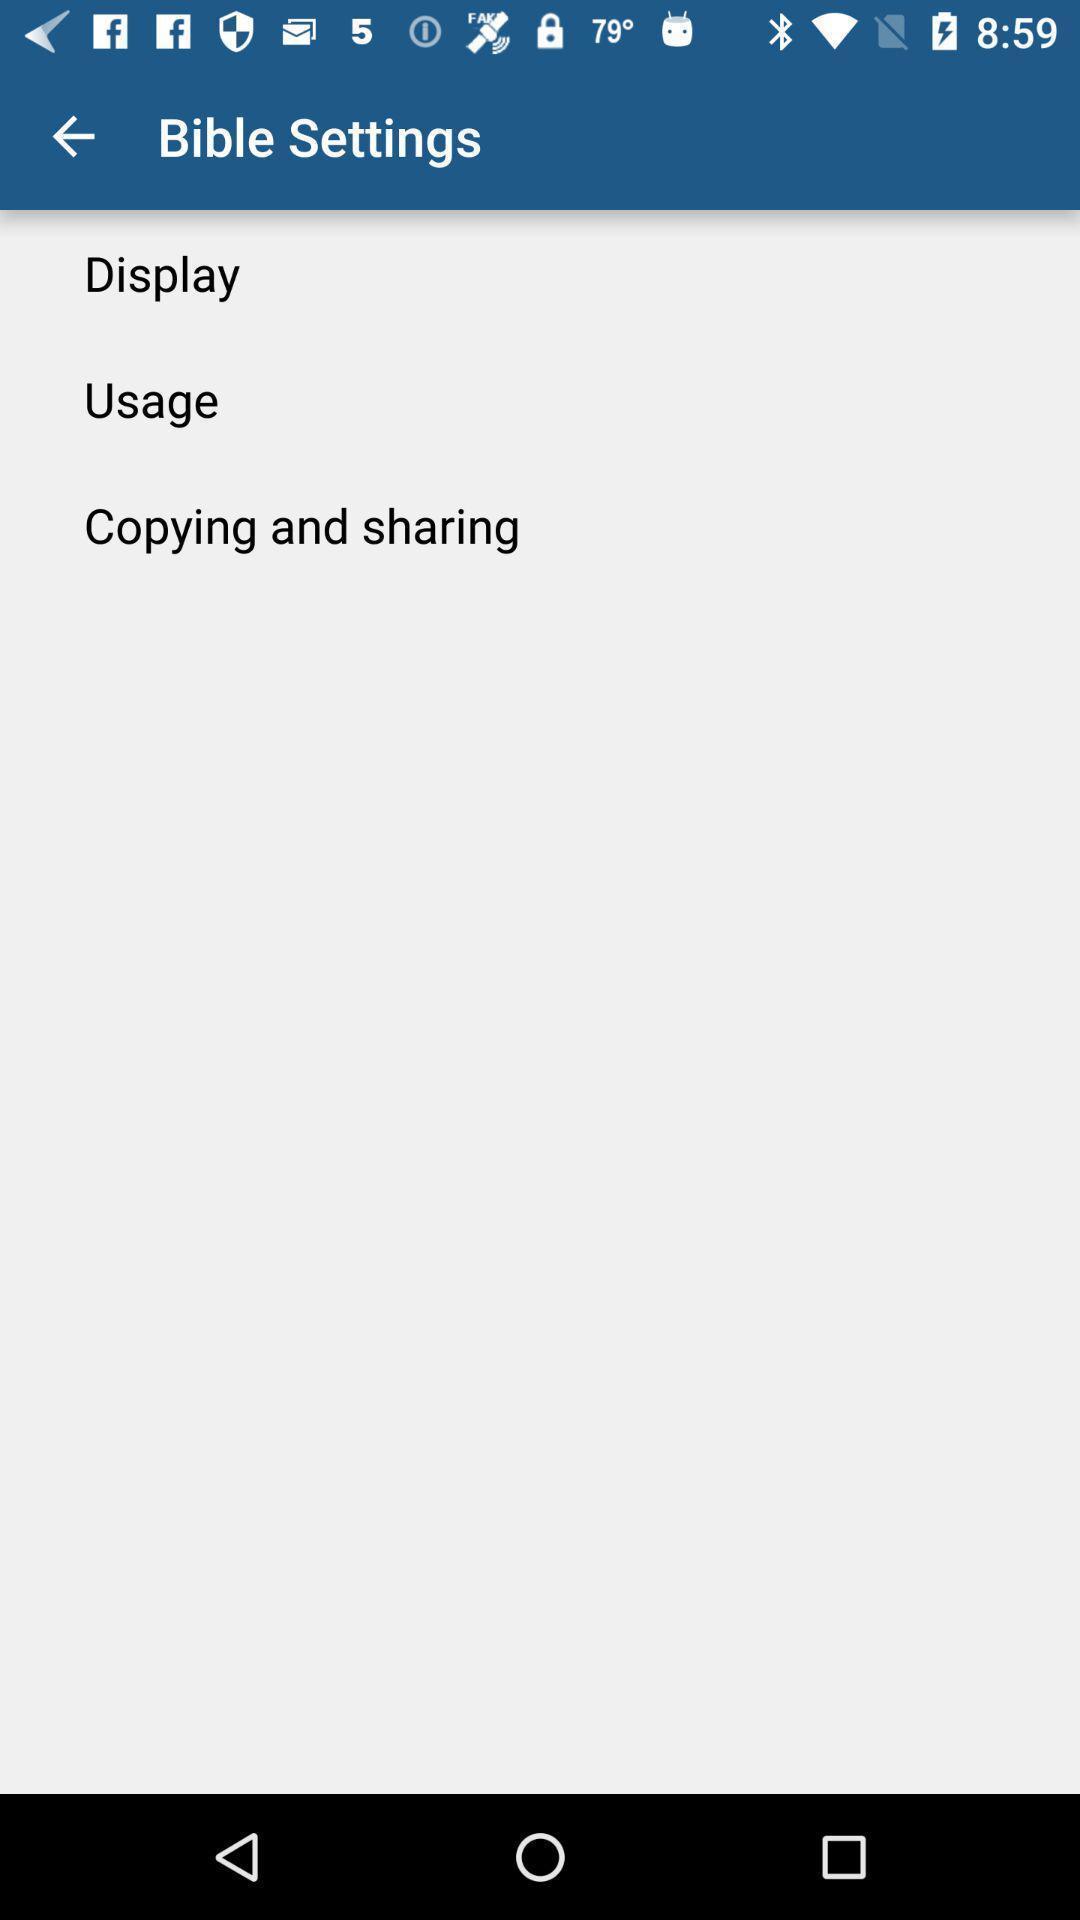Describe this image in words. Settings page displayed of a religious e-book app. 